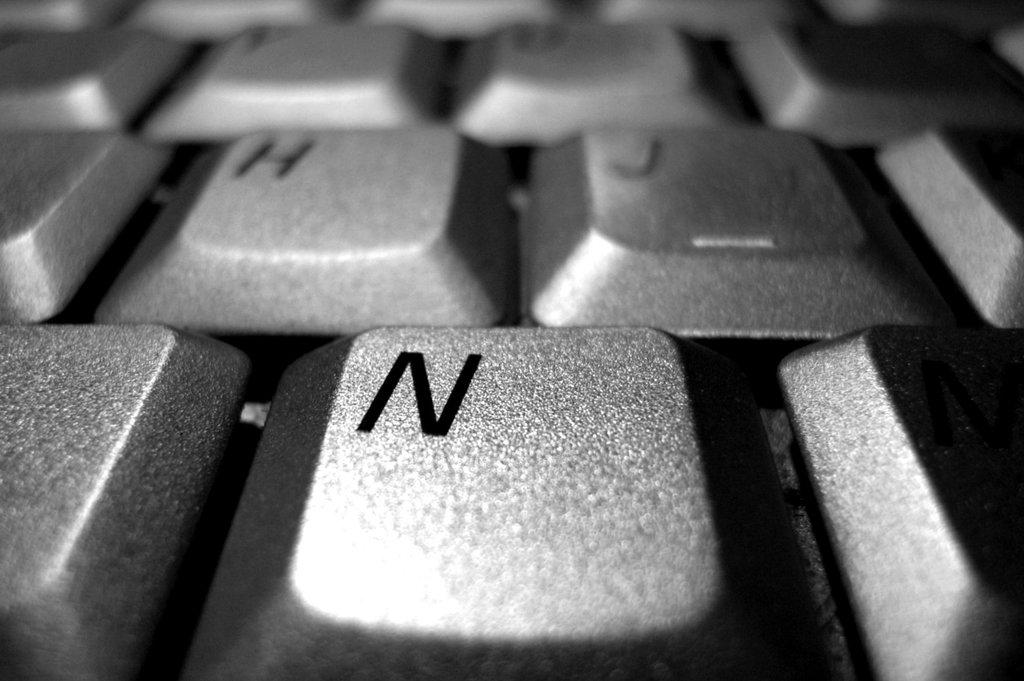Provide a one-sentence caption for the provided image. The main letter shown on this keyboard is N. 